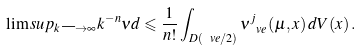Convert formula to latex. <formula><loc_0><loc_0><loc_500><loc_500>\lim s u p _ { k \longrightarrow \infty } k ^ { - n } \nu d \leqslant \frac { 1 } { n ! } \int _ { D ( \ v e / 2 ) } \nu ^ { j } _ { \ v e } { ( \mu , x ) } \, d V ( x ) \, .</formula> 